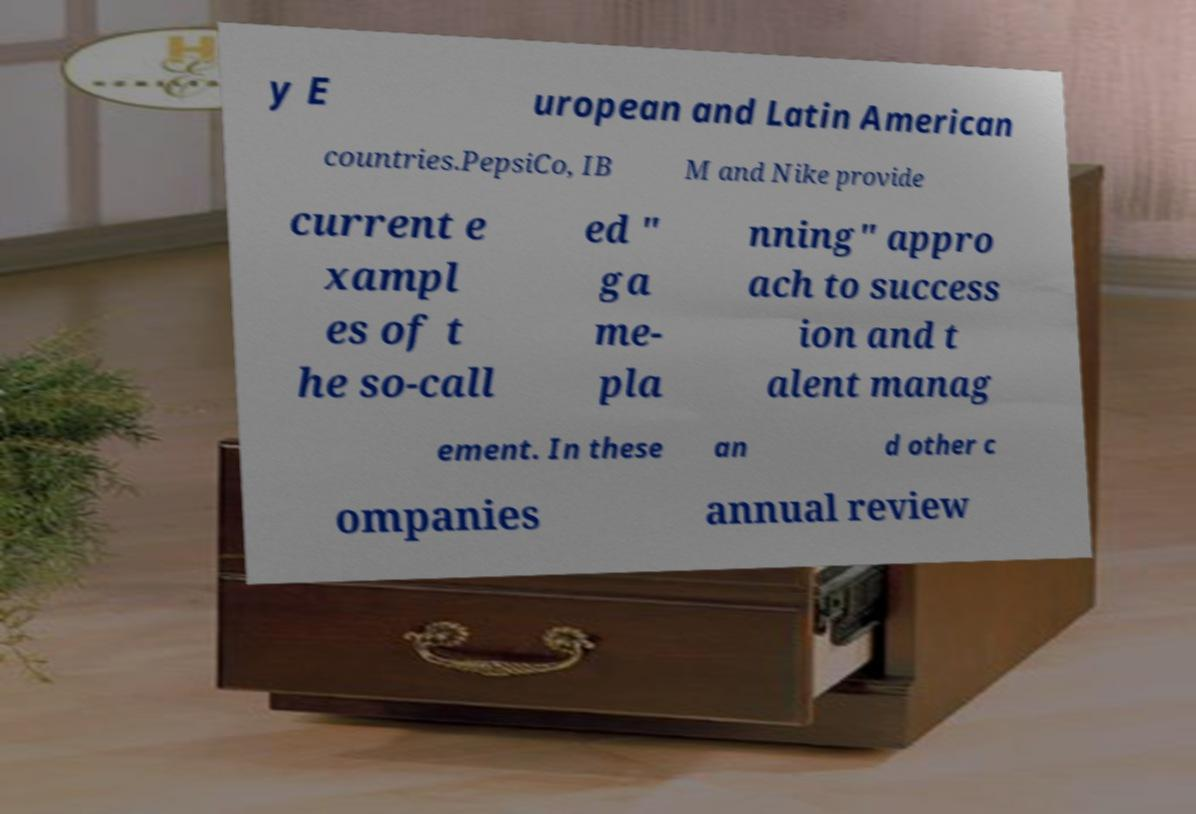For documentation purposes, I need the text within this image transcribed. Could you provide that? y E uropean and Latin American countries.PepsiCo, IB M and Nike provide current e xampl es of t he so-call ed " ga me- pla nning" appro ach to success ion and t alent manag ement. In these an d other c ompanies annual review 